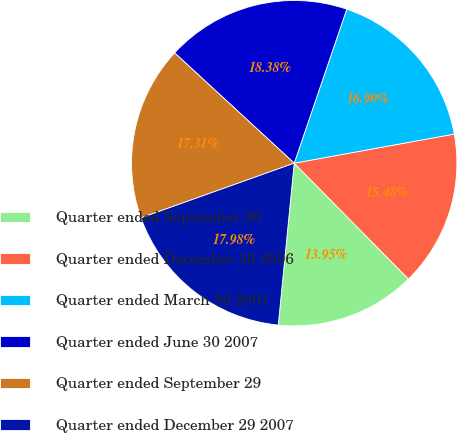<chart> <loc_0><loc_0><loc_500><loc_500><pie_chart><fcel>Quarter ended September 30<fcel>Quarter ended December 30 2006<fcel>Quarter ended March 30 2007<fcel>Quarter ended June 30 2007<fcel>Quarter ended September 29<fcel>Quarter ended December 29 2007<nl><fcel>13.95%<fcel>15.48%<fcel>16.9%<fcel>18.38%<fcel>17.31%<fcel>17.98%<nl></chart> 